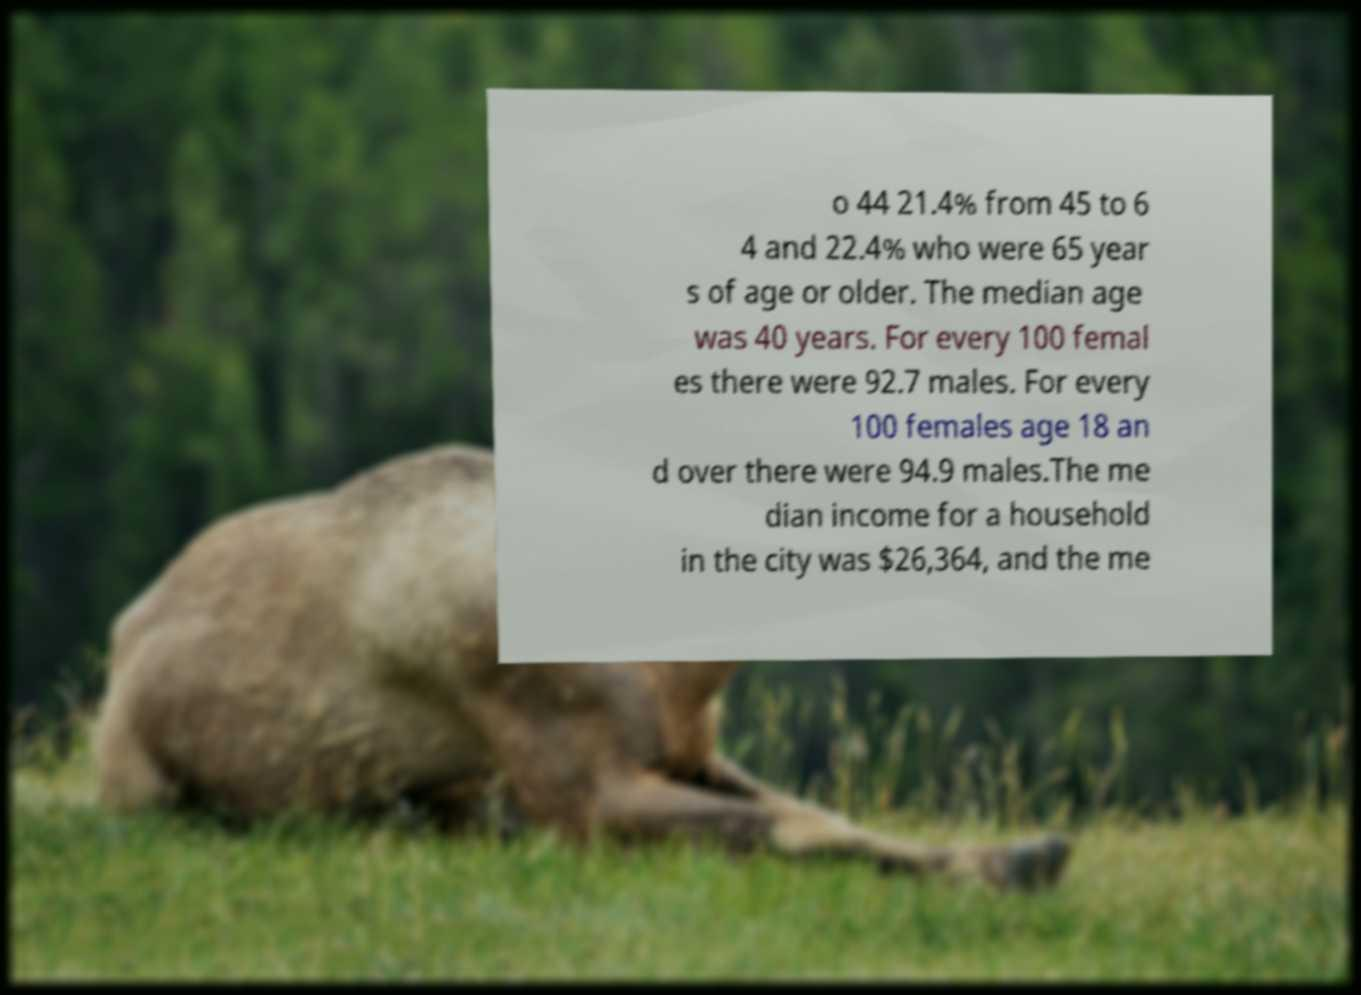Please read and relay the text visible in this image. What does it say? o 44 21.4% from 45 to 6 4 and 22.4% who were 65 year s of age or older. The median age was 40 years. For every 100 femal es there were 92.7 males. For every 100 females age 18 an d over there were 94.9 males.The me dian income for a household in the city was $26,364, and the me 